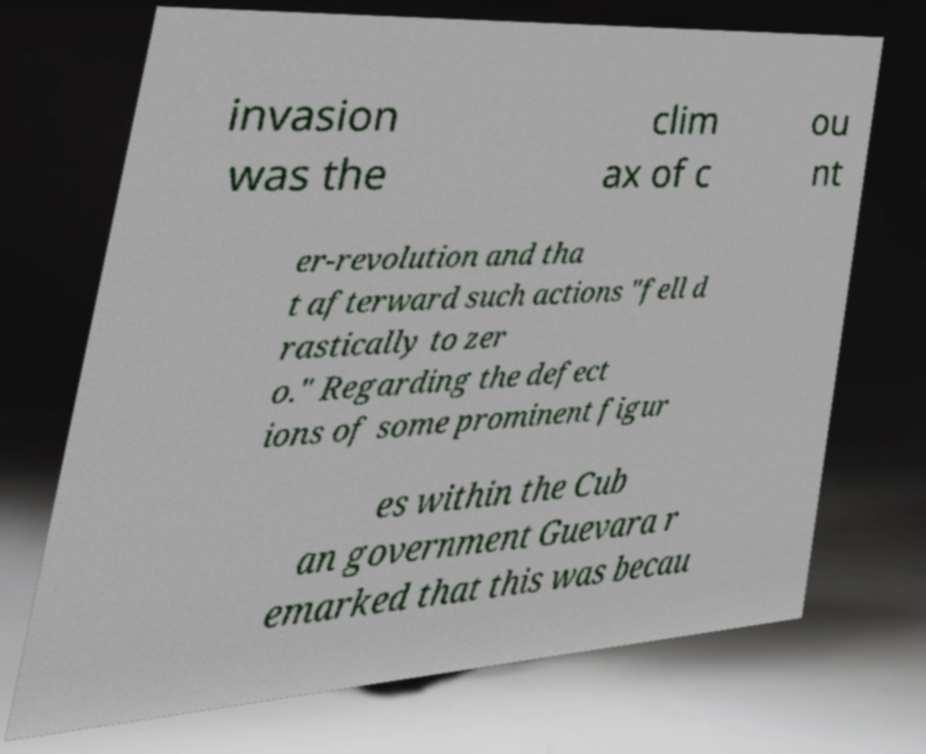There's text embedded in this image that I need extracted. Can you transcribe it verbatim? invasion was the clim ax of c ou nt er-revolution and tha t afterward such actions "fell d rastically to zer o." Regarding the defect ions of some prominent figur es within the Cub an government Guevara r emarked that this was becau 